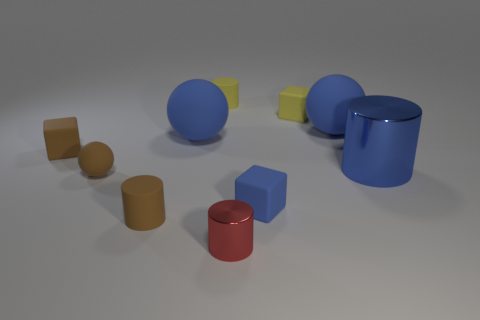Subtract all balls. How many objects are left? 7 Subtract 1 red cylinders. How many objects are left? 9 Subtract all brown spheres. Subtract all large spheres. How many objects are left? 7 Add 9 brown rubber blocks. How many brown rubber blocks are left? 10 Add 3 big shiny objects. How many big shiny objects exist? 4 